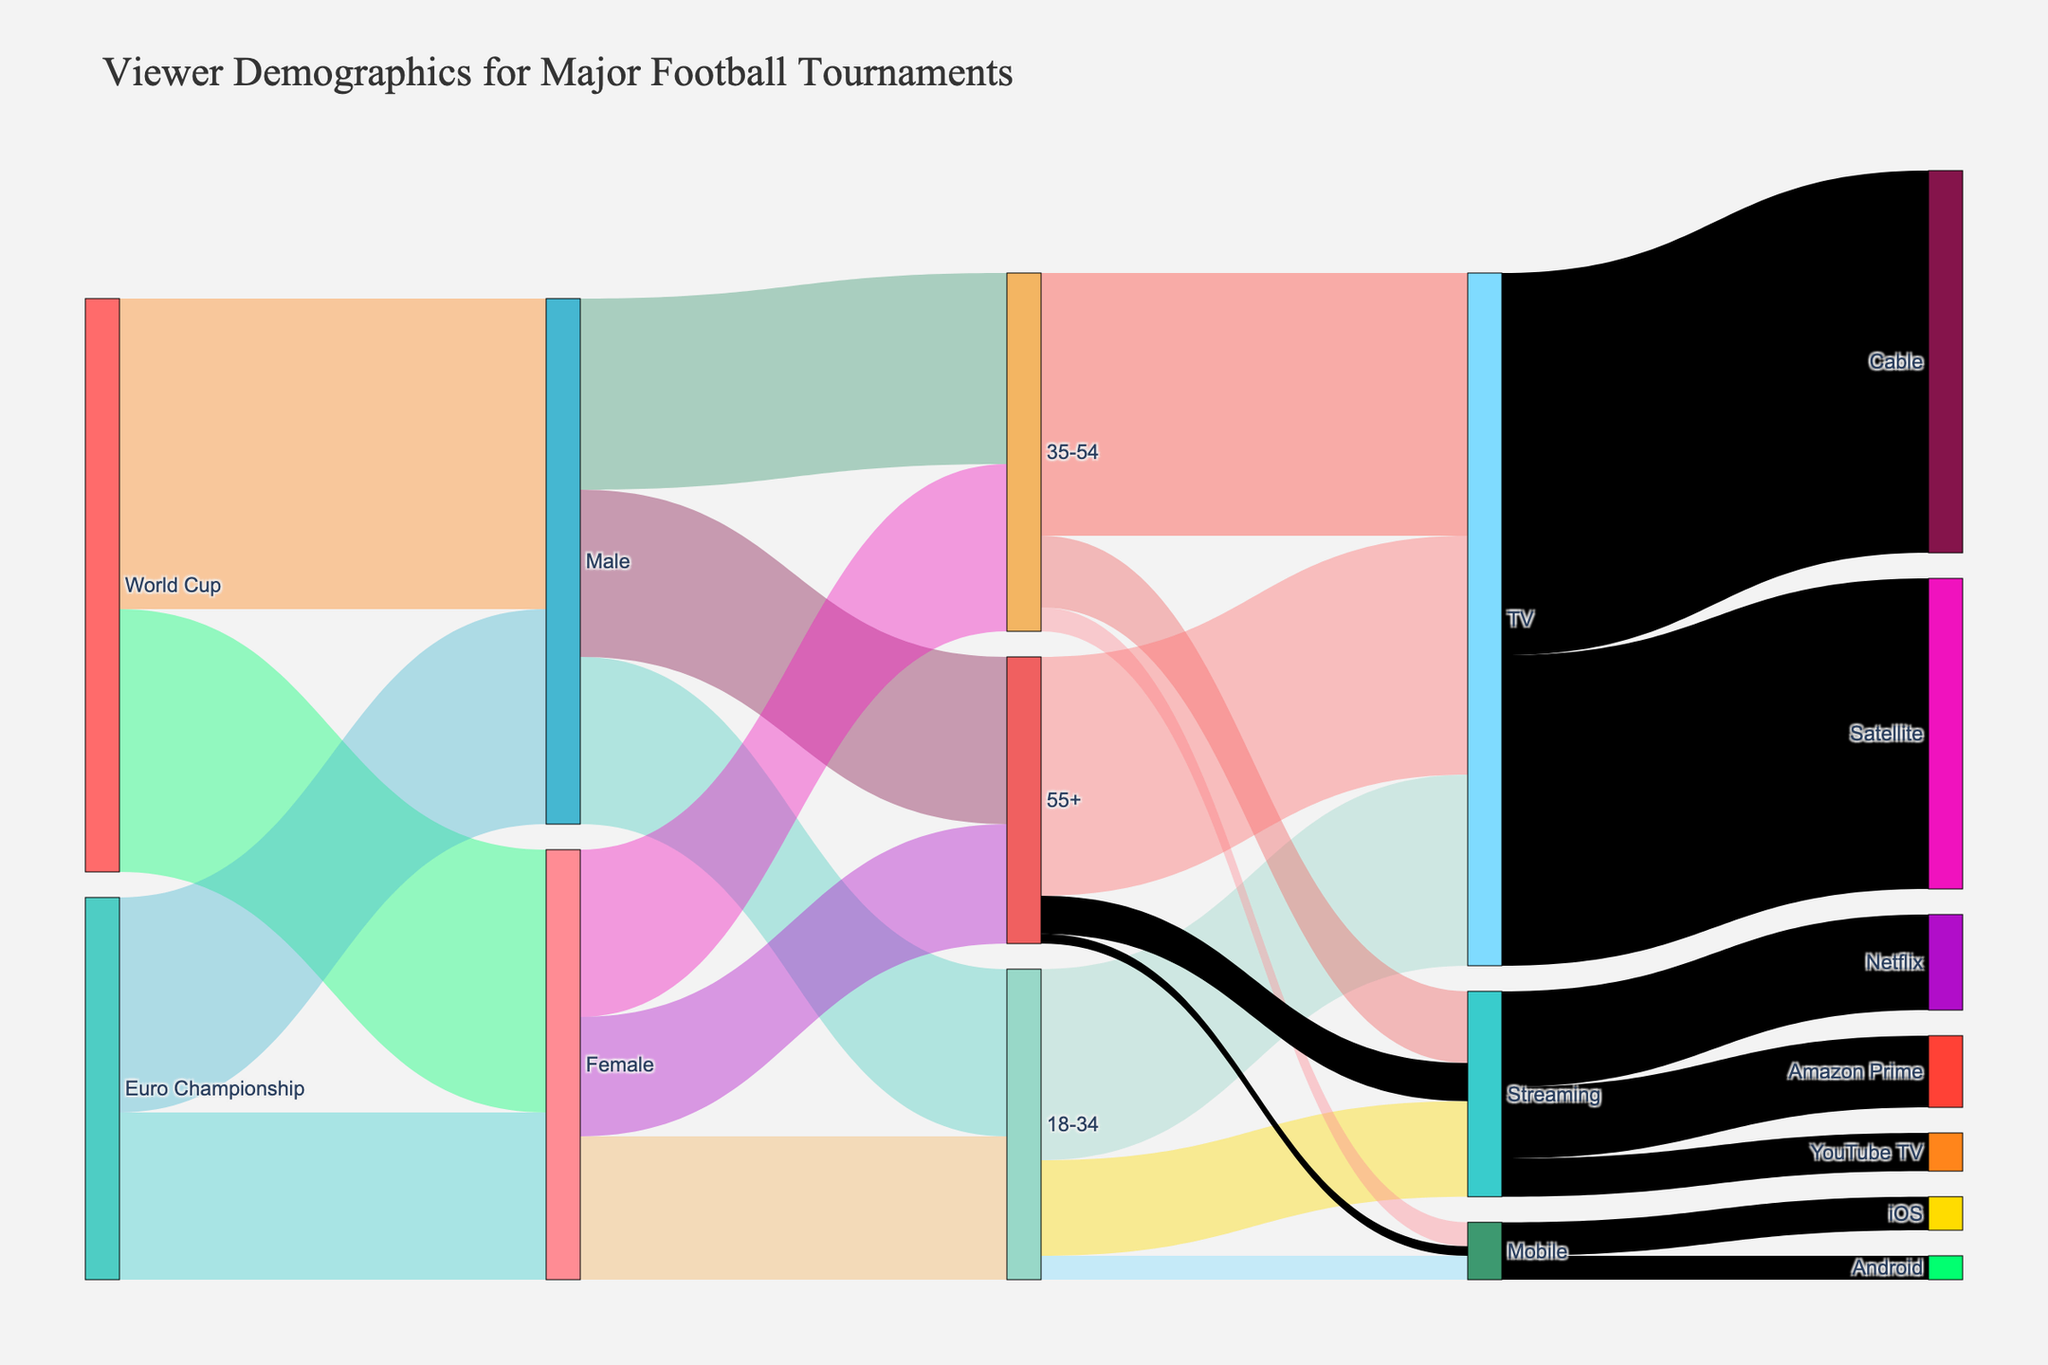Which demographic group has the highest number of viewers for the World Cup? To find this, look at the nodes branching out from "World Cup." Compare the values connected to each demographic group. The values are 65,000,000 for Male viewers and 55,000,000 for Female viewers.
Answer: Male Which age group has the lowest number of female viewers? Look at the branches from "Female" leading to different age groups. The values are 30,000,000 for 18-34, 35,000,000 for 35-54, and 25,000,000 for 55+. The lowest value is 25,000,000 for 55+.
Answer: 55+ How many total viewers watched via TV? Sum the number of viewers from each age group who watched via TV: 40,000,000 (18-34) + 55,000,000 (35-54) + 50,000,000 (55+). The total sum is 145,000,000.
Answer: 145,000,000 What is the difference in the number of viewers between Cable TV and Satellite TV? To calculate the difference, subtract the number of Satellite TV viewers from Cable TV viewers: 80,000,000 (Cable) - 65,000,000 (Satellite) = 15,000,000.
Answer: 15,000,000 Which platform has the least number of viewers? Look at the branches leading to different platforms and compare their values. The values are 80,000,000 for TV, 43,000,000 for Streaming, and 12,000,000 for Mobile. The least number of viewers is for Mobile.
Answer: Mobile Which gender has a higher number of viewers for the Euro Championship? Compare the values connected to "Euro Championship" for both genders. The values are 45,000,000 for Male viewers and 35,000,000 for Female viewers. Males have a higher number of viewers.
Answer: Male How many male viewers are in the 35-54 age group? Look at the branch from "Male" leading to the "35-54" node. The value is 40,000,000.
Answer: 40,000,000 What age group has the highest number of viewers using mobile platforms? Compare the values from each age group that watched via Mobile: 5,000,000 (18-34), 5,000,000 (35-54), and 2,000,000 (55+). The highest number is 5,000,000, shared by the 18-34 and 35-54 groups.
Answer: 18-34 and 35-54 Between Amazon Prime and YouTube TV, which streaming service has more viewers? Compare the values connected to "Amazon Prime" and "YouTube TV." The values are 15,000,000 for Amazon Prime and 8,000,000 for YouTube TV. Amazon Prime has more viewers.
Answer: Amazon Prime What is the total number of viewers for the "Streaming" platform? Sum the values branching out from "Streaming" to each of its sub-platforms: 20,000,000 (Netflix) + 15,000,000 (Amazon Prime) + 8,000,000 (YouTube TV). The total sum is 43,000,000.
Answer: 43,000,000 